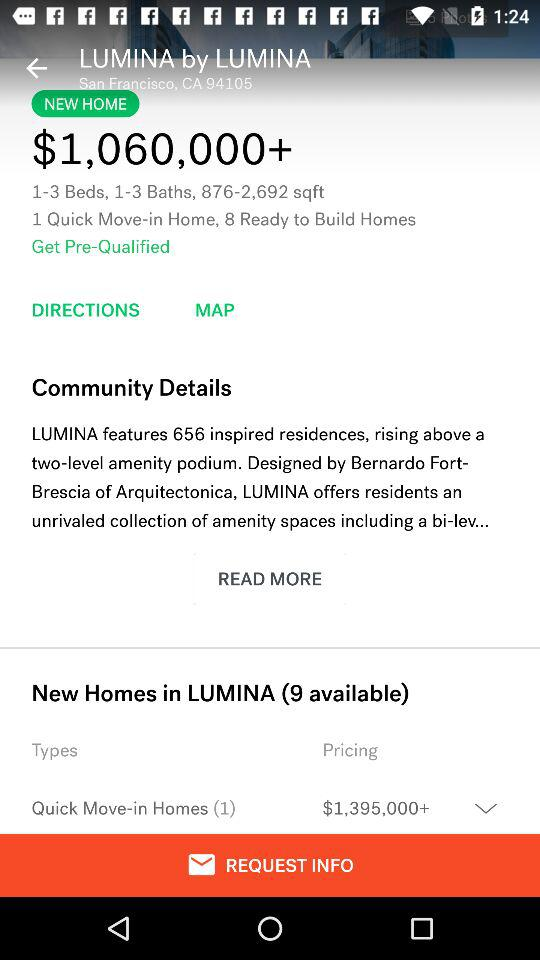How many new homes are available in "LUMINA"? There are 9 new homes available in "LUMINA". 